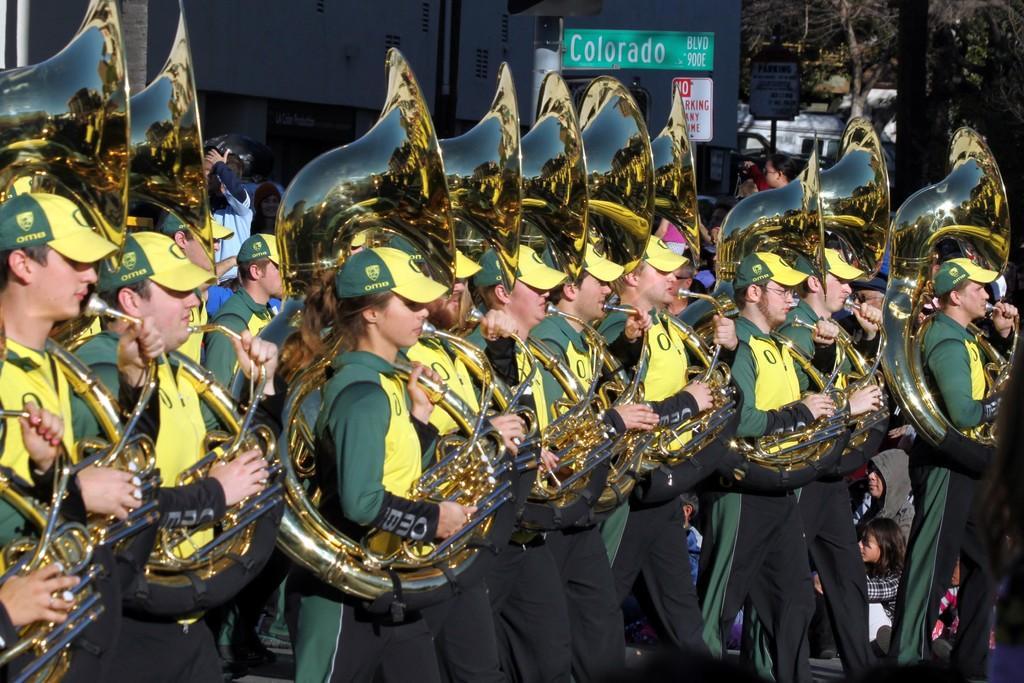Please provide a concise description of this image. In this picture I can see a group of people are standing and playing musical instrument. These people are wearing caps. In the background I can see trees and boards. 